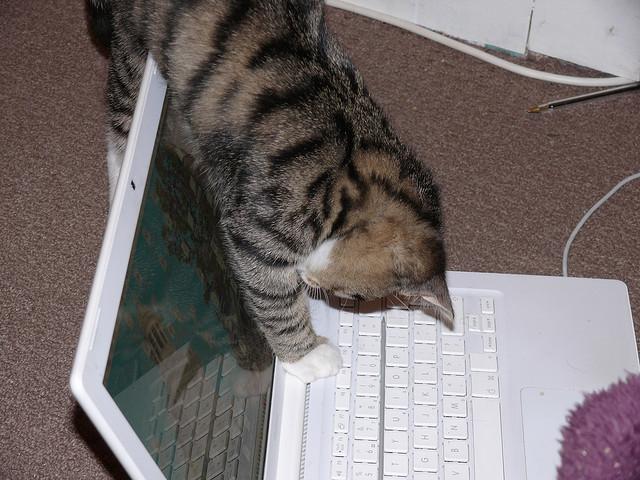Does the cat know how to use the computer?
Give a very brief answer. No. Is the laptop clean?
Short answer required. Yes. What is the animal doing?
Quick response, please. Playing. What is the cat looking down from?
Concise answer only. Laptop. What color are the stripes on the cat?
Short answer required. Black. Is that a USB cord?
Quick response, please. Yes. Is the animal using the computer?
Answer briefly. No. What is the cat doing?
Short answer required. Typing. 